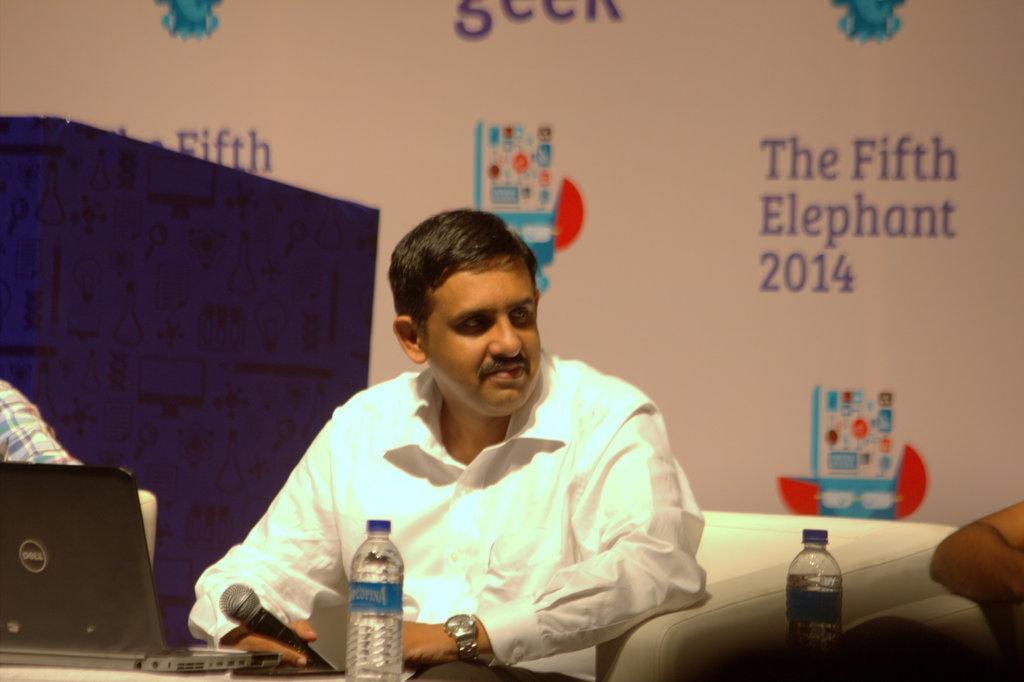Describe this image in one or two sentences. In this image I can see a man is sitting and I can see he is holding a mic, I can also see he is wearing white colour shirt and a watch. Here I can see a laptop, few bottles and a hand of a person. In the background I can see a white colour thing and on it I can see something is written at few places. 